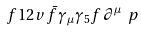Convert formula to latex. <formula><loc_0><loc_0><loc_500><loc_500>\ f { 1 } { 2 v } \, \bar { f } \gamma _ { \mu } \gamma _ { 5 } f \, \partial ^ { \mu } \ p</formula> 